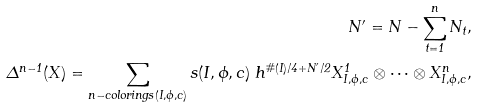Convert formula to latex. <formula><loc_0><loc_0><loc_500><loc_500>N ^ { \prime } = N - \sum _ { t = 1 } ^ { n } N _ { t } , \\ \Delta ^ { n - 1 } ( X ) = \sum _ { n - c o l o r i n g s ( I , \phi , c ) } s ( I , \phi , c ) \ h ^ { \# ( I ) / 4 + N ^ { \prime } / 2 } X _ { I , \phi , c } ^ { 1 } \otimes \cdots \otimes X _ { I , \phi , c } ^ { n } ,</formula> 